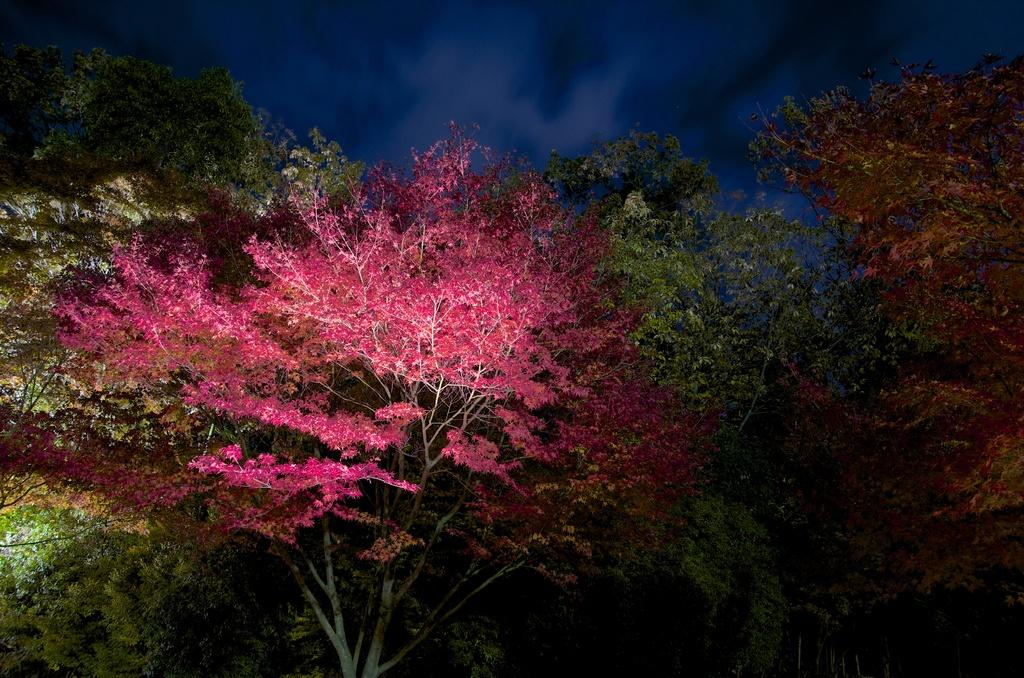What is located in the center of the image? There are trees in the center of the image. What is visible at the top of the image? The sky is visible at the top of the image. How many ducks can be seen swimming in the trees in the image? There are no ducks present in the image; it features trees and the sky. What type of cub is hiding among the branches of the trees in the image? There is no cub present in the image; it only features trees and the sky. 